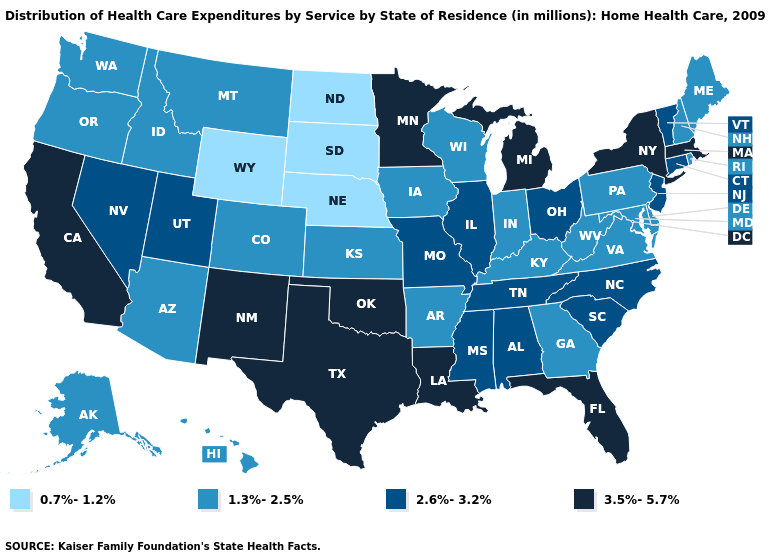How many symbols are there in the legend?
Concise answer only. 4. What is the value of Texas?
Answer briefly. 3.5%-5.7%. Name the states that have a value in the range 1.3%-2.5%?
Concise answer only. Alaska, Arizona, Arkansas, Colorado, Delaware, Georgia, Hawaii, Idaho, Indiana, Iowa, Kansas, Kentucky, Maine, Maryland, Montana, New Hampshire, Oregon, Pennsylvania, Rhode Island, Virginia, Washington, West Virginia, Wisconsin. Does Wyoming have the lowest value in the West?
Answer briefly. Yes. Does New Mexico have the highest value in the West?
Give a very brief answer. Yes. Name the states that have a value in the range 0.7%-1.2%?
Concise answer only. Nebraska, North Dakota, South Dakota, Wyoming. Does Tennessee have the lowest value in the South?
Quick response, please. No. Name the states that have a value in the range 3.5%-5.7%?
Short answer required. California, Florida, Louisiana, Massachusetts, Michigan, Minnesota, New Mexico, New York, Oklahoma, Texas. Which states have the lowest value in the West?
Short answer required. Wyoming. What is the value of North Dakota?
Concise answer only. 0.7%-1.2%. Does Maryland have a higher value than North Dakota?
Keep it brief. Yes. What is the value of New Hampshire?
Short answer required. 1.3%-2.5%. Name the states that have a value in the range 2.6%-3.2%?
Quick response, please. Alabama, Connecticut, Illinois, Mississippi, Missouri, Nevada, New Jersey, North Carolina, Ohio, South Carolina, Tennessee, Utah, Vermont. What is the value of Hawaii?
Be succinct. 1.3%-2.5%. What is the value of Vermont?
Write a very short answer. 2.6%-3.2%. 